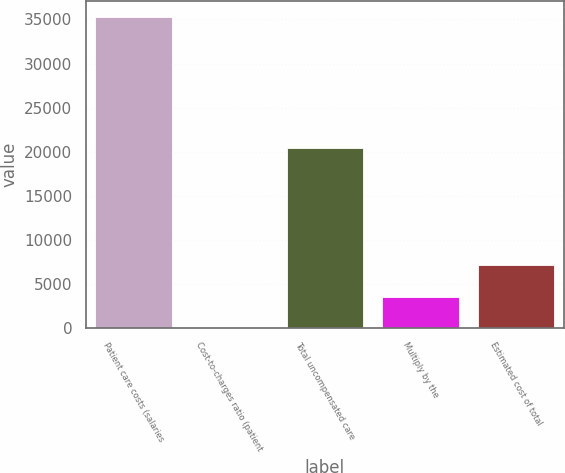<chart> <loc_0><loc_0><loc_500><loc_500><bar_chart><fcel>Patient care costs (salaries<fcel>Cost-to-charges ratio (patient<fcel>Total uncompensated care<fcel>Multiply by the<fcel>Estimated cost of total<nl><fcel>35304<fcel>13.5<fcel>20455<fcel>3542.55<fcel>7071.6<nl></chart> 